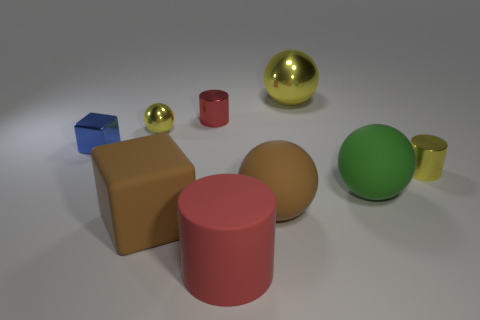Does the big rubber cylinder have the same color as the small metallic cylinder to the left of the large red object?
Ensure brevity in your answer.  Yes. What shape is the tiny object that is the same color as the small sphere?
Your answer should be compact. Cylinder. What number of big yellow spheres are to the left of the tiny metallic cylinder that is behind the tiny yellow metal thing in front of the blue thing?
Your answer should be very brief. 0. The other cylinder that is the same size as the yellow cylinder is what color?
Ensure brevity in your answer.  Red. How big is the yellow metal ball in front of the tiny metallic cylinder that is behind the tiny ball?
Your answer should be very brief. Small. There is another ball that is the same color as the tiny metal ball; what size is it?
Keep it short and to the point. Large. How many other objects are there of the same size as the red metal object?
Your response must be concise. 3. How many red cylinders are there?
Offer a very short reply. 2. Is the size of the blue block the same as the brown cube?
Offer a terse response. No. How many other things are the same shape as the large green object?
Your answer should be compact. 3. 